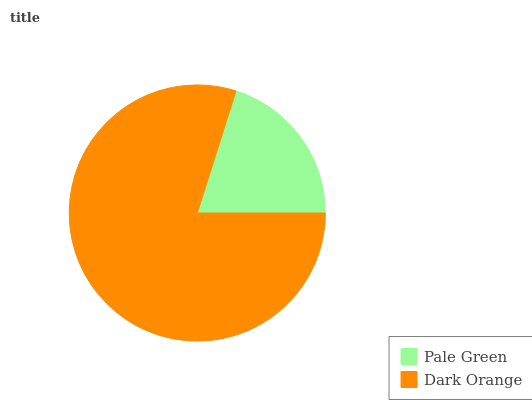Is Pale Green the minimum?
Answer yes or no. Yes. Is Dark Orange the maximum?
Answer yes or no. Yes. Is Dark Orange the minimum?
Answer yes or no. No. Is Dark Orange greater than Pale Green?
Answer yes or no. Yes. Is Pale Green less than Dark Orange?
Answer yes or no. Yes. Is Pale Green greater than Dark Orange?
Answer yes or no. No. Is Dark Orange less than Pale Green?
Answer yes or no. No. Is Dark Orange the high median?
Answer yes or no. Yes. Is Pale Green the low median?
Answer yes or no. Yes. Is Pale Green the high median?
Answer yes or no. No. Is Dark Orange the low median?
Answer yes or no. No. 